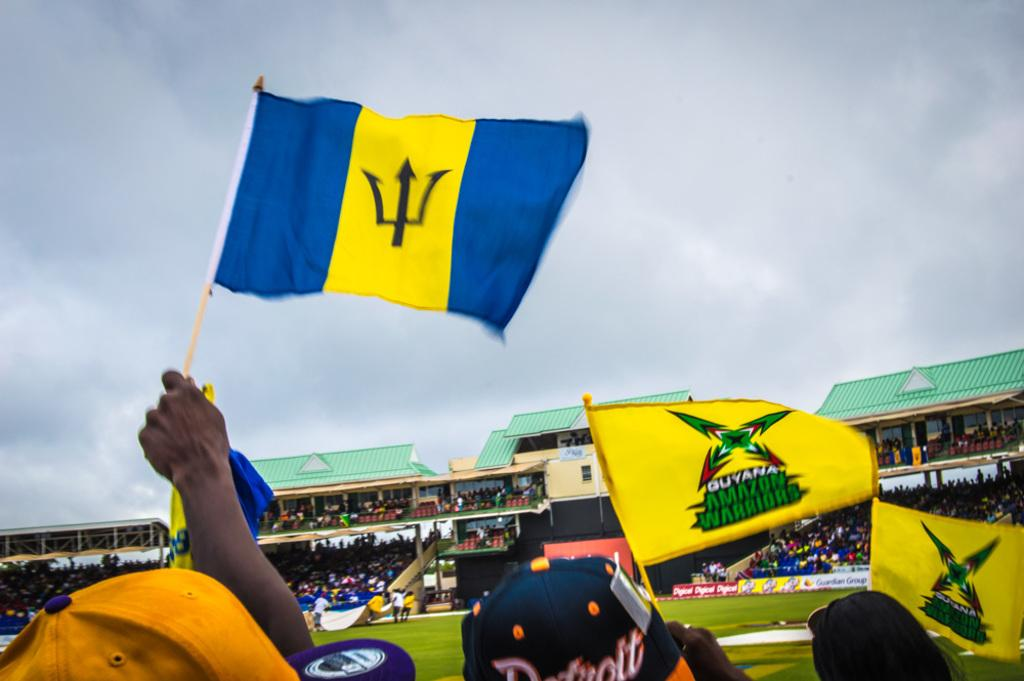What are the persons at the bottom of the image holding? The persons at the bottom of the image are holding flags. Can you describe the scene in the background of the image? In the background of the image, there are persons visible, grass, a crowd, buildings, and the sky with clouds. How many elements can be seen in the background of the image? There are six elements visible in the background of the image: persons, grass, a crowd, buildings, the sky, and clouds. What type of pies can be seen on the lamp in the image? There is no lamp or pies present in the image. Can you tell me how many glasses of milk are visible in the image? There are no glasses of milk visible in the image. 